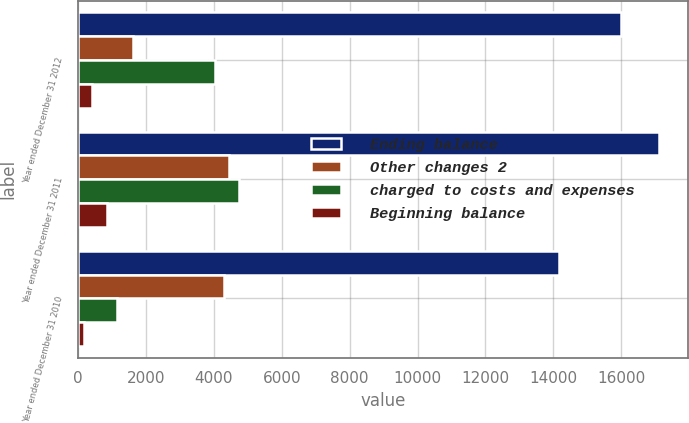<chart> <loc_0><loc_0><loc_500><loc_500><stacked_bar_chart><ecel><fcel>Year ended December 31 2012<fcel>Year ended December 31 2011<fcel>Year ended December 31 2010<nl><fcel>Ending balance<fcel>16000<fcel>17119<fcel>14154<nl><fcel>Other changes 2<fcel>1615<fcel>4447<fcel>4300<nl><fcel>charged to costs and expenses<fcel>4040<fcel>4724<fcel>1152<nl><fcel>Beginning balance<fcel>420<fcel>842<fcel>183<nl></chart> 